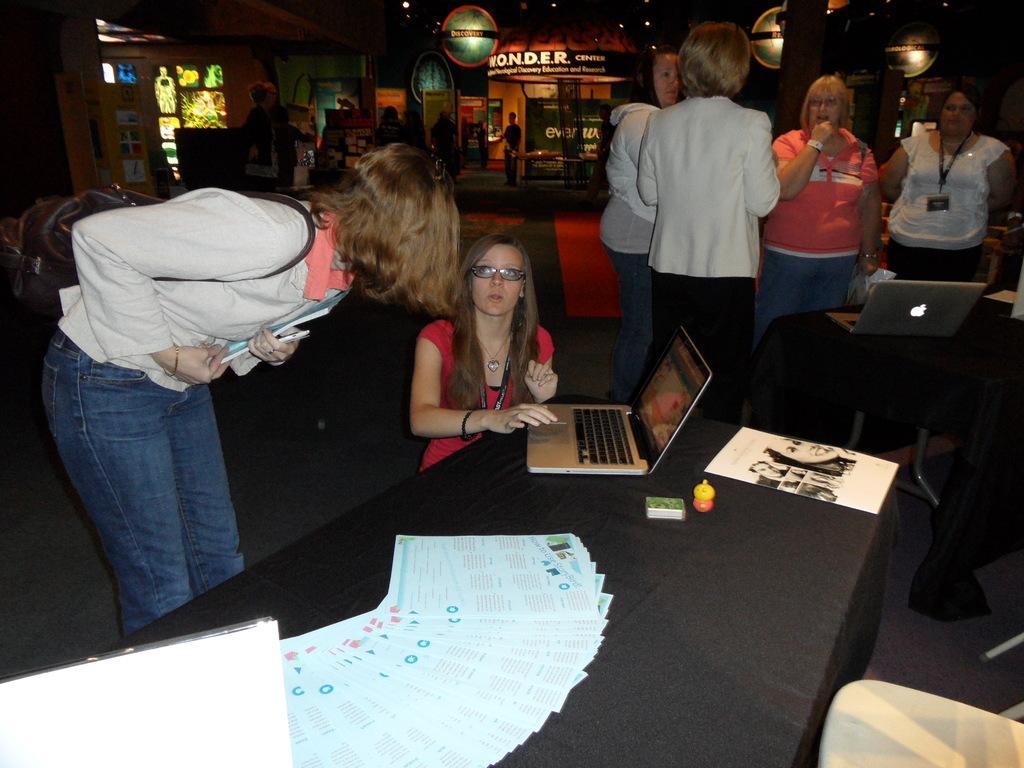Please provide a concise description of this image. In this image, we can see many people and there is a girl sitting, we can see a laptop, papers which are placed on the table and in the background, there is building and name boards. 